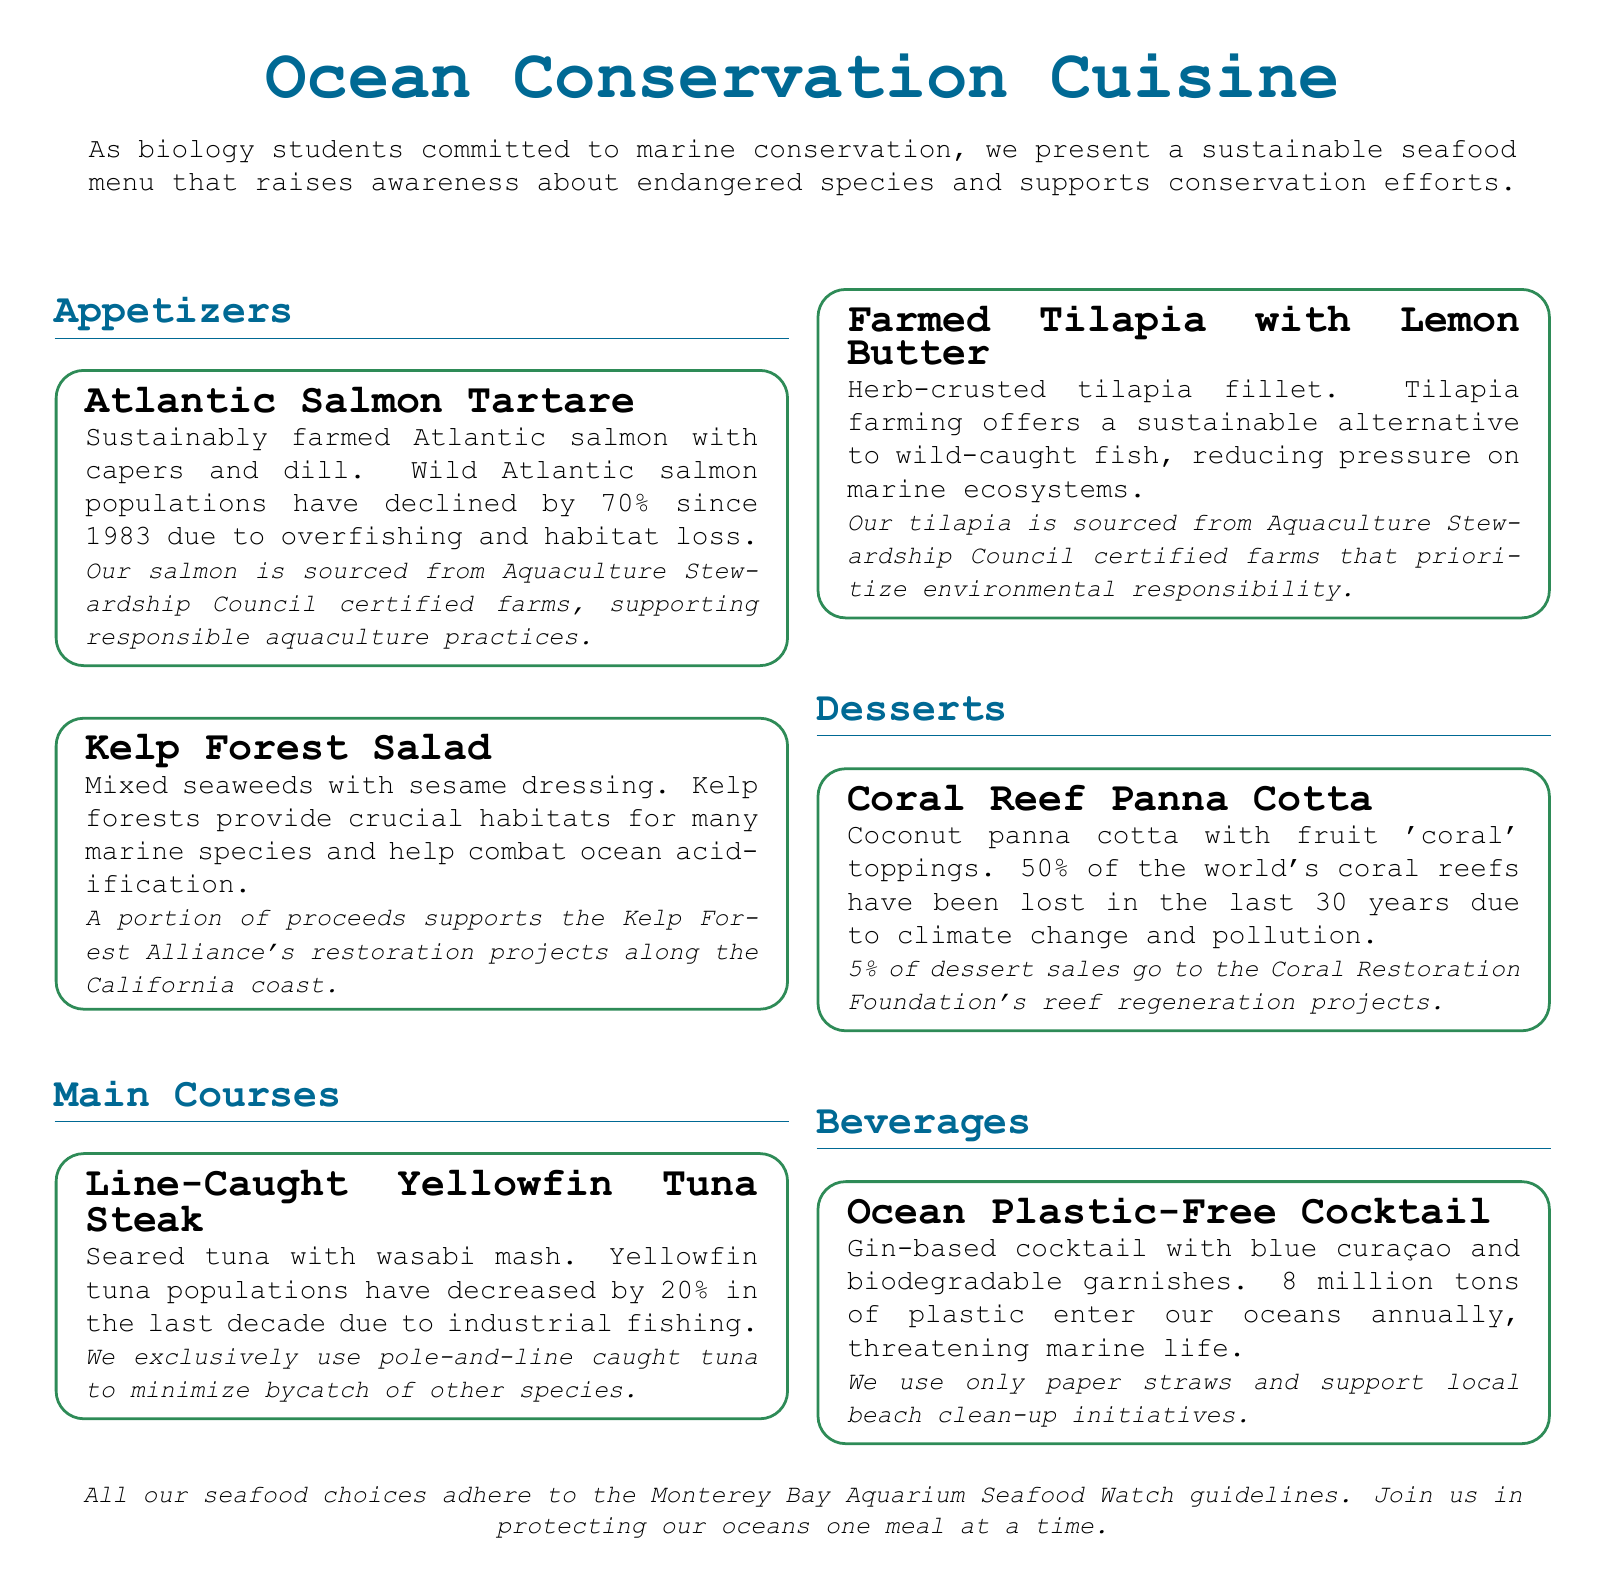What is the title of the menu? The title is presented at the top of the document and is "Ocean Conservation Cuisine."
Answer: Ocean Conservation Cuisine What percentage have wild Atlantic salmon populations declined since 1983? The menu item mentions that wild Atlantic salmon populations have declined by 70% since 1983.
Answer: 70% What organization certifies the salmon farms used in the menu? The menu specifies that the salmon is sourced from Aquaculture Stewardship Council certified farms.
Answer: Aquaculture Stewardship Council What is the focus of the Kelp Forest Alliance? The menu states that a portion of the proceeds supports the Kelp Forest Alliance's restoration projects.
Answer: Restoration projects What percentage of dessert sales go to the Coral Restoration Foundation? The document mentions that 5% of dessert sales go to the Coral Restoration Foundation.
Answer: 5% What type of tuna is exclusively used in the main course? The menu item for tuna indicates that they exclusively use pole-and-line caught tuna.
Answer: Pole-and-line caught What environmental issue does the Ocean Plastic-Free Cocktail highlight? According to the menu, 8 million tons of plastic enter our oceans annually, threatening marine life.
Answer: Plastic pollution Which beverage uses biodegradable garnishes? The menu clearly states that the Ocean Plastic-Free Cocktail has biodegradable garnishes.
Answer: Ocean Plastic-Free Cocktail What is the role of the Monterey Bay Aquarium Seafood Watch in the context of this menu? The last statement indicates that all seafood choices adhere to the Monterey Bay Aquarium Seafood Watch guidelines.
Answer: Seafood choices guidelines 